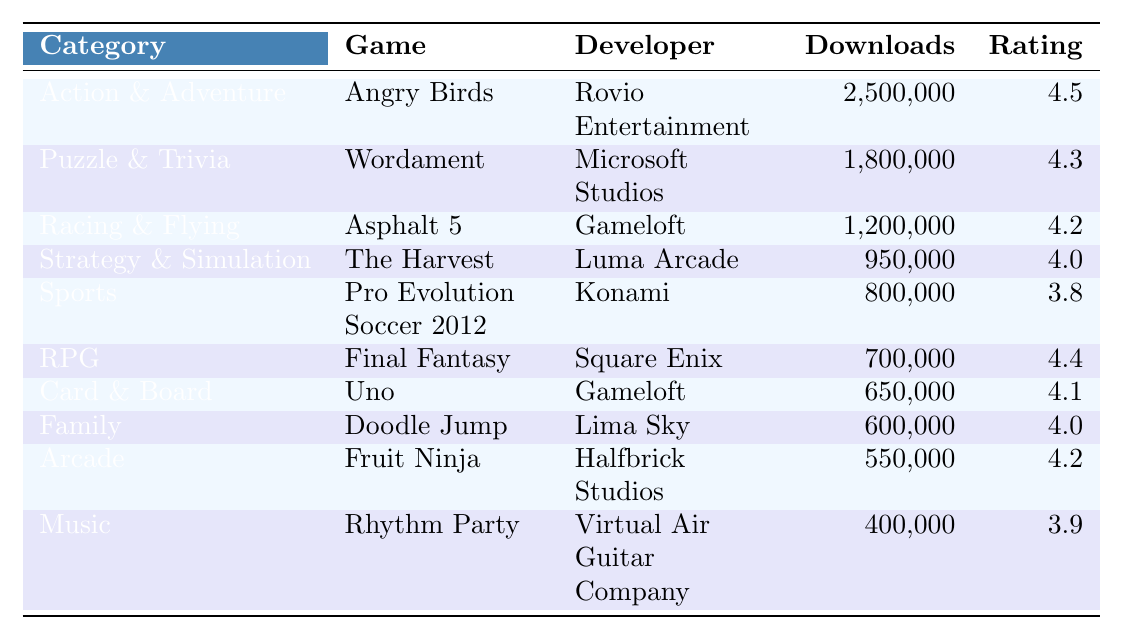What is the most downloaded game in the Action & Adventure category? The table shows that "Angry Birds" is in the Action & Adventure category, with 2,500,000 downloads, which is higher than any other game in that category.
Answer: Angry Birds How many downloads does "Final Fantasy" have? Looking at the table, "Final Fantasy" has 700,000 downloads listed under the RPG category.
Answer: 700,000 Which game has the highest average rating in the table? The highest average rating in the table is 4.5 for "Angry Birds," which is more than any other game listed.
Answer: Angry Birds What is the total number of downloads for the Racing & Flying category? The table lists "Asphalt 5" under Racing & Flying with 1,200,000 downloads. Therefore, the total for this category is 1,200,000.
Answer: 1,200,000 What is the difference in download counts between "Doodle Jump" and "Uno"? "Doodle Jump" has 600,000 downloads and "Uno" has 650,000 downloads. The difference is 650,000 - 600,000 = 50,000 downloads.
Answer: 50,000 Is "Pro Evolution Soccer 2012" rated higher than 4.0? The average rating for "Pro Evolution Soccer 2012" is 3.8, which is lower than 4.0. Therefore, the answer is no.
Answer: No How many games have an average rating of 4.0 or higher? The games with an average rating of 4.0 or higher are "Angry Birds", "Wordament", "Asphalt 5", "Final Fantasy", "Uno", "Doodle Jump", and "Fruit Ninja", totaling 7 games.
Answer: 7 games What is the average number of downloads for games in the Sports category? In the Sports category, "Pro Evolution Soccer 2012" has 800,000 downloads. Since it's the only game listed, the average is simply 800,000.
Answer: 800,000 Which category has the least number of downloads? By looking at the table, the "Music" category has the least downloads with 400,000 as it is lower than all other categories.
Answer: Music If we combine the downloads of the Card & Board and Family categories, what is the total? "Uno" in the Card & Board category has 650,000 downloads and "Doodle Jump" in the Family category has 600,000. The total downloads are 650,000 + 600,000 = 1,250,000.
Answer: 1,250,000 